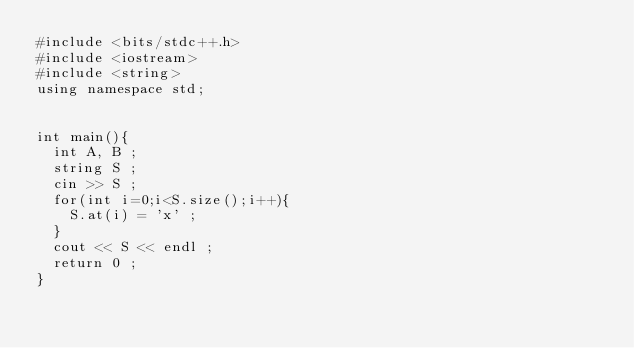Convert code to text. <code><loc_0><loc_0><loc_500><loc_500><_C++_>#include <bits/stdc++.h>
#include <iostream>
#include <string>
using namespace std;


int main(){
  int A, B ;
  string S ;
  cin >> S ;
  for(int i=0;i<S.size();i++){
    S.at(i) = 'x' ;
  }  
  cout << S << endl ;
  return 0 ;
}</code> 